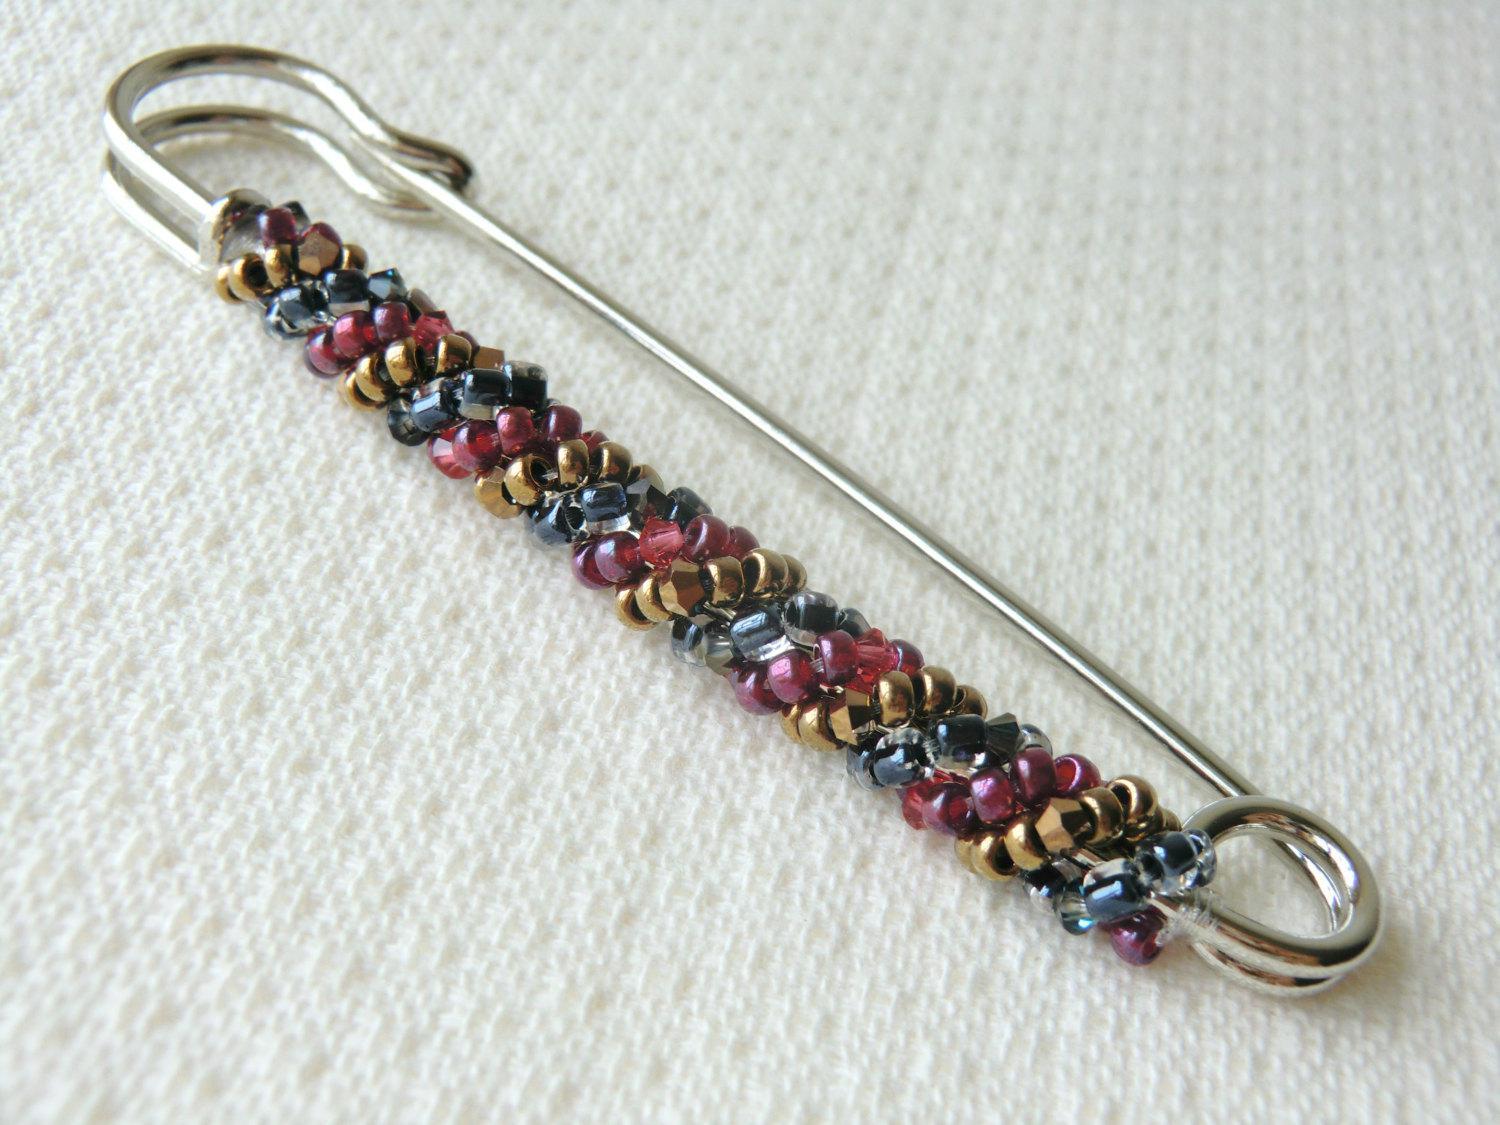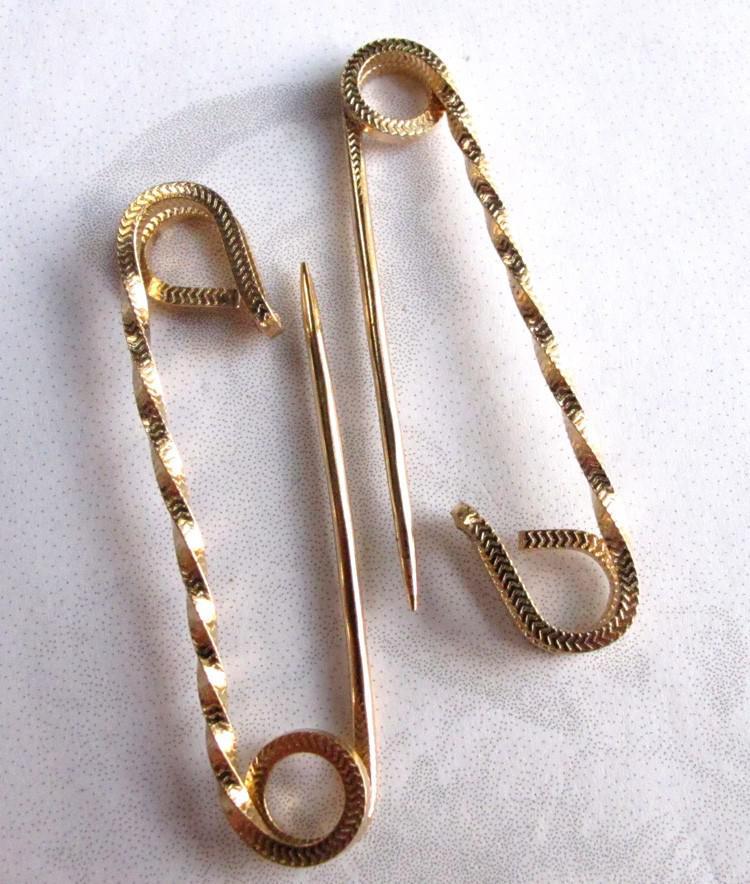The first image is the image on the left, the second image is the image on the right. Examine the images to the left and right. Is the description "There is a feather in one of the images." accurate? Answer yes or no. No. 